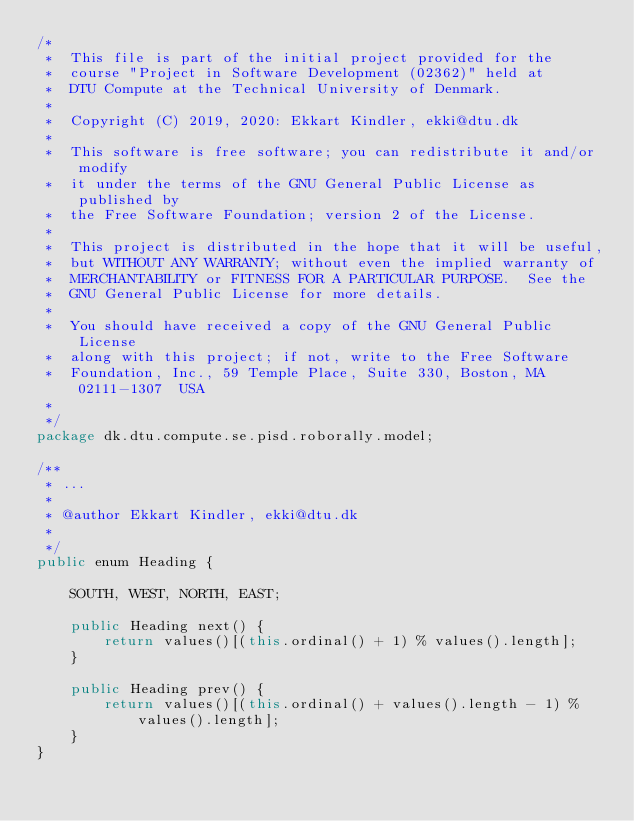Convert code to text. <code><loc_0><loc_0><loc_500><loc_500><_Java_>/*
 *  This file is part of the initial project provided for the
 *  course "Project in Software Development (02362)" held at
 *  DTU Compute at the Technical University of Denmark.
 *
 *  Copyright (C) 2019, 2020: Ekkart Kindler, ekki@dtu.dk
 *
 *  This software is free software; you can redistribute it and/or modify
 *  it under the terms of the GNU General Public License as published by
 *  the Free Software Foundation; version 2 of the License.
 *
 *  This project is distributed in the hope that it will be useful,
 *  but WITHOUT ANY WARRANTY; without even the implied warranty of
 *  MERCHANTABILITY or FITNESS FOR A PARTICULAR PURPOSE.  See the
 *  GNU General Public License for more details.
 *
 *  You should have received a copy of the GNU General Public License
 *  along with this project; if not, write to the Free Software
 *  Foundation, Inc., 59 Temple Place, Suite 330, Boston, MA  02111-1307  USA
 *
 */
package dk.dtu.compute.se.pisd.roborally.model;

/**
 * ...
 *
 * @author Ekkart Kindler, ekki@dtu.dk
 *
 */
public enum Heading {

    SOUTH, WEST, NORTH, EAST;

    public Heading next() {
        return values()[(this.ordinal() + 1) % values().length];
    }

    public Heading prev() {
        return values()[(this.ordinal() + values().length - 1) % values().length];
    }
}
</code> 